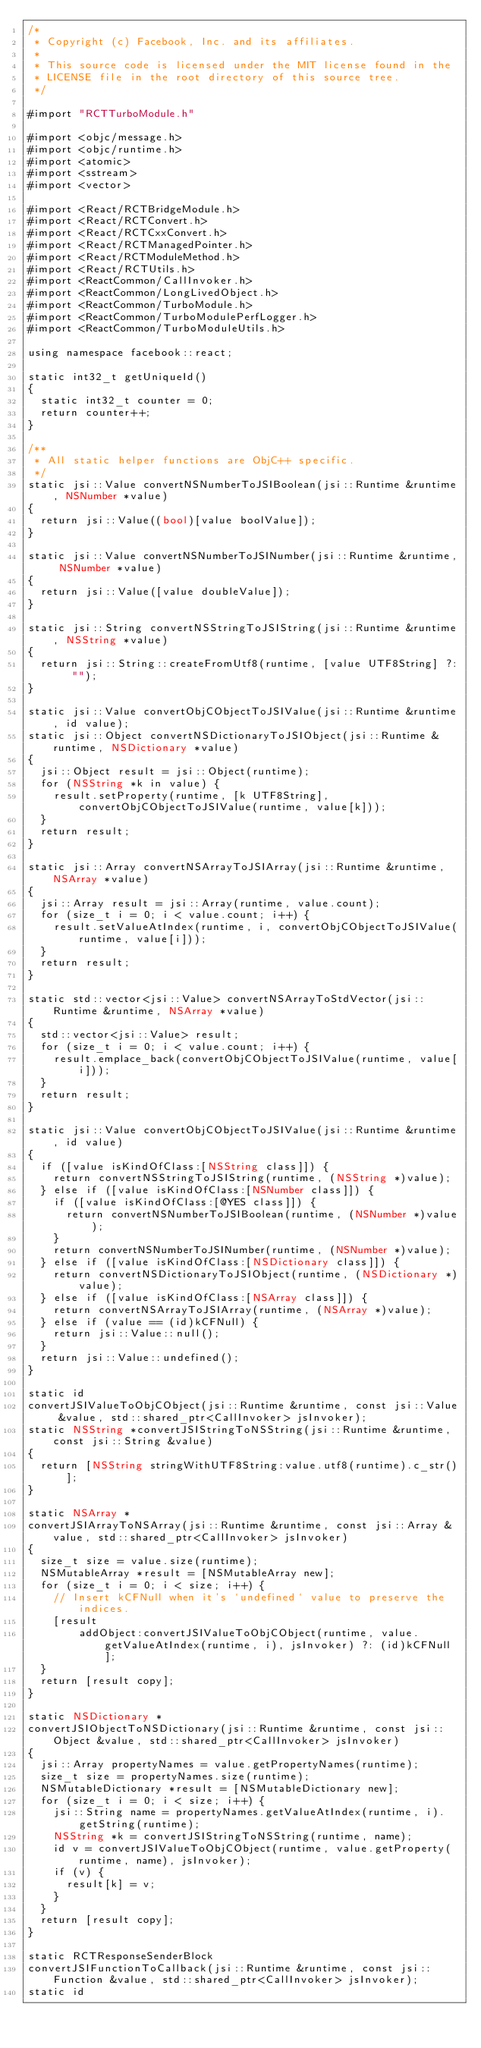Convert code to text. <code><loc_0><loc_0><loc_500><loc_500><_ObjectiveC_>/*
 * Copyright (c) Facebook, Inc. and its affiliates.
 *
 * This source code is licensed under the MIT license found in the
 * LICENSE file in the root directory of this source tree.
 */

#import "RCTTurboModule.h"

#import <objc/message.h>
#import <objc/runtime.h>
#import <atomic>
#import <sstream>
#import <vector>

#import <React/RCTBridgeModule.h>
#import <React/RCTConvert.h>
#import <React/RCTCxxConvert.h>
#import <React/RCTManagedPointer.h>
#import <React/RCTModuleMethod.h>
#import <React/RCTUtils.h>
#import <ReactCommon/CallInvoker.h>
#import <ReactCommon/LongLivedObject.h>
#import <ReactCommon/TurboModule.h>
#import <ReactCommon/TurboModulePerfLogger.h>
#import <ReactCommon/TurboModuleUtils.h>

using namespace facebook::react;

static int32_t getUniqueId()
{
  static int32_t counter = 0;
  return counter++;
}

/**
 * All static helper functions are ObjC++ specific.
 */
static jsi::Value convertNSNumberToJSIBoolean(jsi::Runtime &runtime, NSNumber *value)
{
  return jsi::Value((bool)[value boolValue]);
}

static jsi::Value convertNSNumberToJSINumber(jsi::Runtime &runtime, NSNumber *value)
{
  return jsi::Value([value doubleValue]);
}

static jsi::String convertNSStringToJSIString(jsi::Runtime &runtime, NSString *value)
{
  return jsi::String::createFromUtf8(runtime, [value UTF8String] ?: "");
}

static jsi::Value convertObjCObjectToJSIValue(jsi::Runtime &runtime, id value);
static jsi::Object convertNSDictionaryToJSIObject(jsi::Runtime &runtime, NSDictionary *value)
{
  jsi::Object result = jsi::Object(runtime);
  for (NSString *k in value) {
    result.setProperty(runtime, [k UTF8String], convertObjCObjectToJSIValue(runtime, value[k]));
  }
  return result;
}

static jsi::Array convertNSArrayToJSIArray(jsi::Runtime &runtime, NSArray *value)
{
  jsi::Array result = jsi::Array(runtime, value.count);
  for (size_t i = 0; i < value.count; i++) {
    result.setValueAtIndex(runtime, i, convertObjCObjectToJSIValue(runtime, value[i]));
  }
  return result;
}

static std::vector<jsi::Value> convertNSArrayToStdVector(jsi::Runtime &runtime, NSArray *value)
{
  std::vector<jsi::Value> result;
  for (size_t i = 0; i < value.count; i++) {
    result.emplace_back(convertObjCObjectToJSIValue(runtime, value[i]));
  }
  return result;
}

static jsi::Value convertObjCObjectToJSIValue(jsi::Runtime &runtime, id value)
{
  if ([value isKindOfClass:[NSString class]]) {
    return convertNSStringToJSIString(runtime, (NSString *)value);
  } else if ([value isKindOfClass:[NSNumber class]]) {
    if ([value isKindOfClass:[@YES class]]) {
      return convertNSNumberToJSIBoolean(runtime, (NSNumber *)value);
    }
    return convertNSNumberToJSINumber(runtime, (NSNumber *)value);
  } else if ([value isKindOfClass:[NSDictionary class]]) {
    return convertNSDictionaryToJSIObject(runtime, (NSDictionary *)value);
  } else if ([value isKindOfClass:[NSArray class]]) {
    return convertNSArrayToJSIArray(runtime, (NSArray *)value);
  } else if (value == (id)kCFNull) {
    return jsi::Value::null();
  }
  return jsi::Value::undefined();
}

static id
convertJSIValueToObjCObject(jsi::Runtime &runtime, const jsi::Value &value, std::shared_ptr<CallInvoker> jsInvoker);
static NSString *convertJSIStringToNSString(jsi::Runtime &runtime, const jsi::String &value)
{
  return [NSString stringWithUTF8String:value.utf8(runtime).c_str()];
}

static NSArray *
convertJSIArrayToNSArray(jsi::Runtime &runtime, const jsi::Array &value, std::shared_ptr<CallInvoker> jsInvoker)
{
  size_t size = value.size(runtime);
  NSMutableArray *result = [NSMutableArray new];
  for (size_t i = 0; i < size; i++) {
    // Insert kCFNull when it's `undefined` value to preserve the indices.
    [result
        addObject:convertJSIValueToObjCObject(runtime, value.getValueAtIndex(runtime, i), jsInvoker) ?: (id)kCFNull];
  }
  return [result copy];
}

static NSDictionary *
convertJSIObjectToNSDictionary(jsi::Runtime &runtime, const jsi::Object &value, std::shared_ptr<CallInvoker> jsInvoker)
{
  jsi::Array propertyNames = value.getPropertyNames(runtime);
  size_t size = propertyNames.size(runtime);
  NSMutableDictionary *result = [NSMutableDictionary new];
  for (size_t i = 0; i < size; i++) {
    jsi::String name = propertyNames.getValueAtIndex(runtime, i).getString(runtime);
    NSString *k = convertJSIStringToNSString(runtime, name);
    id v = convertJSIValueToObjCObject(runtime, value.getProperty(runtime, name), jsInvoker);
    if (v) {
      result[k] = v;
    }
  }
  return [result copy];
}

static RCTResponseSenderBlock
convertJSIFunctionToCallback(jsi::Runtime &runtime, const jsi::Function &value, std::shared_ptr<CallInvoker> jsInvoker);
static id</code> 